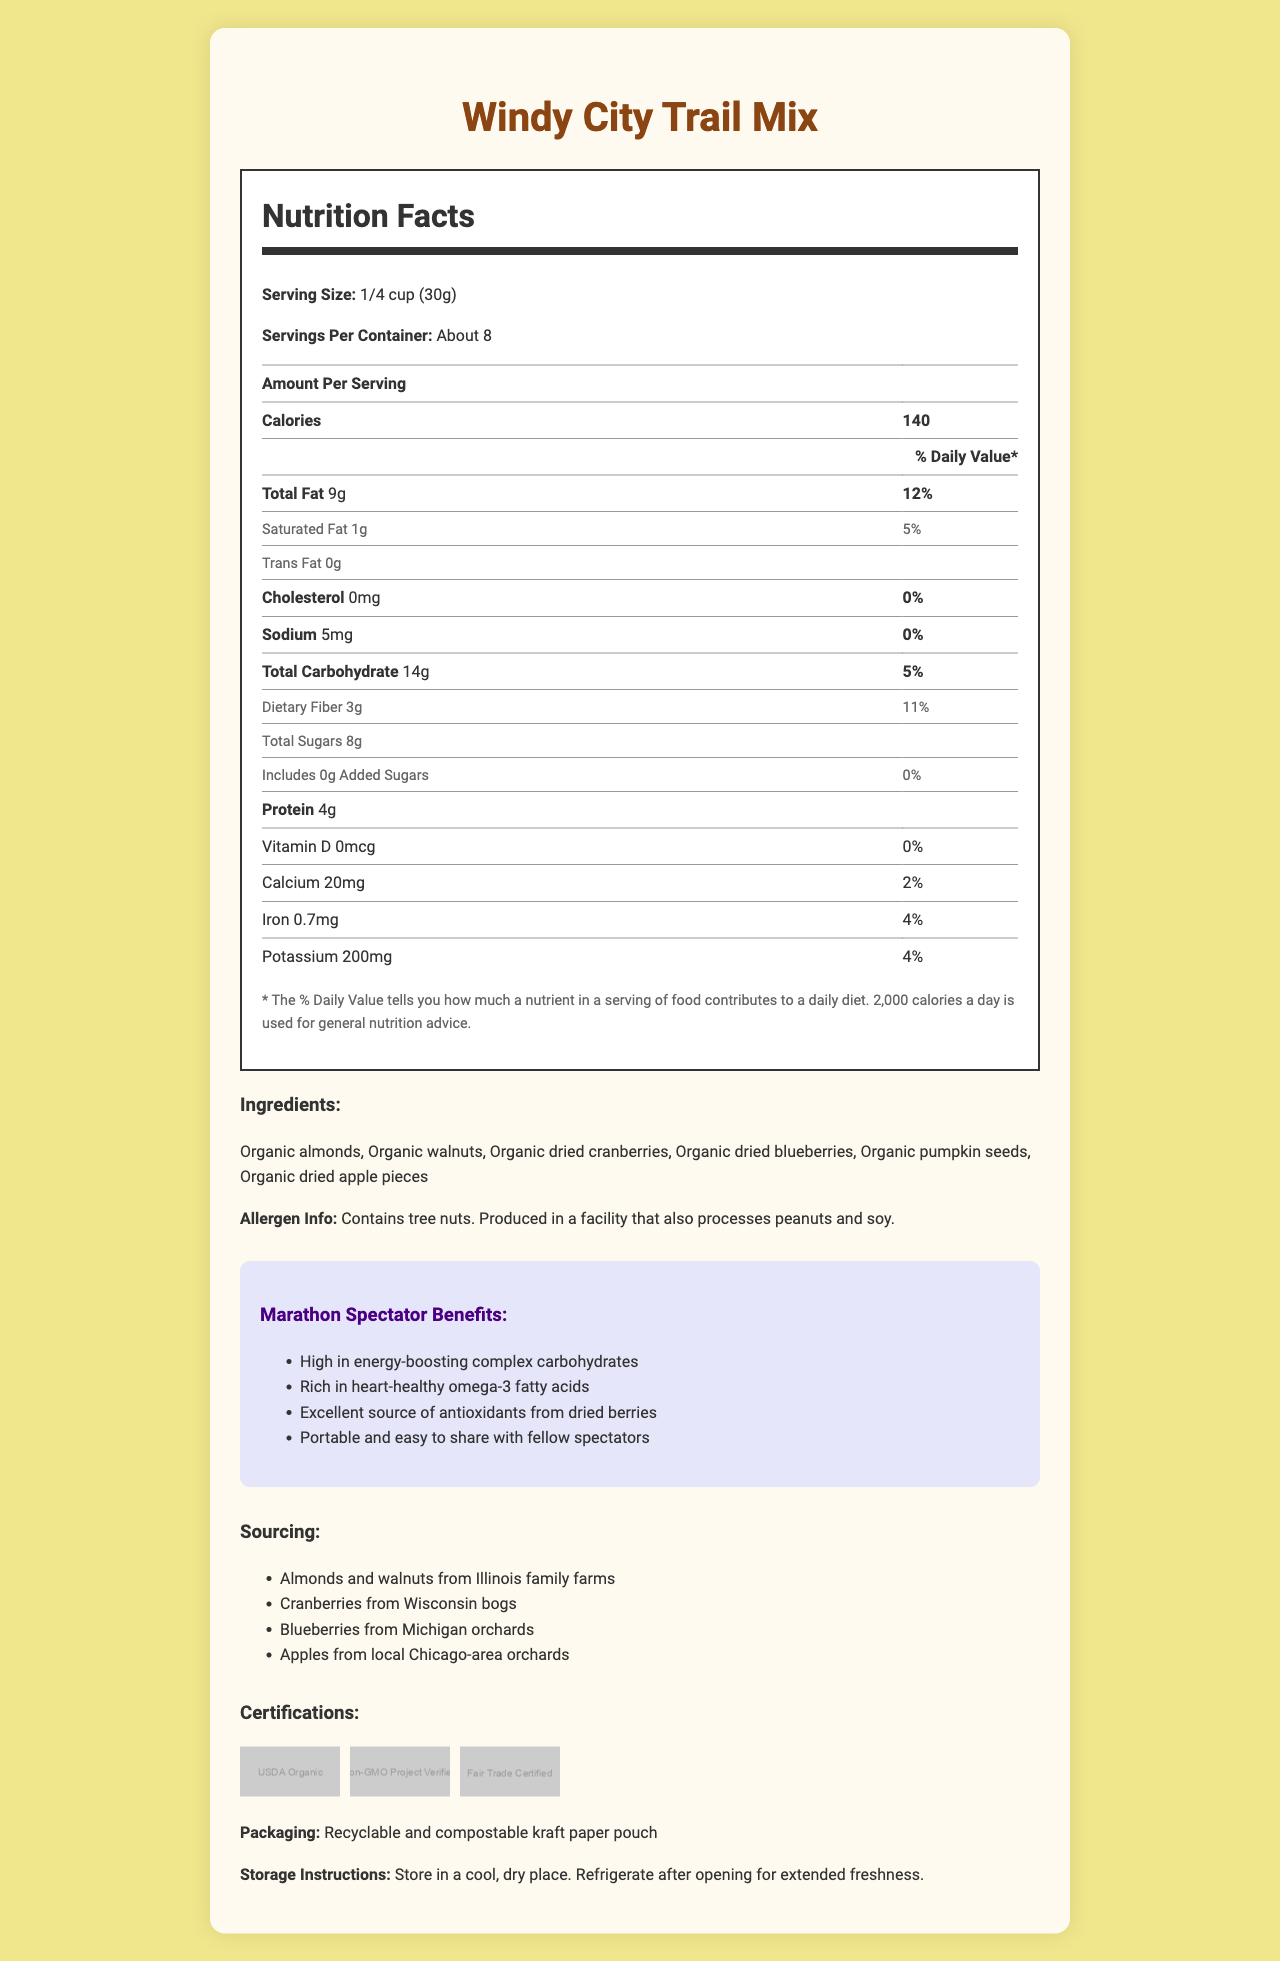How many calories are in one serving of Windy City Trail Mix? The calories per serving are listed as 140 in the nutrition facts section.
Answer: 140 What is the serving size of the Windy City Trail Mix? The serving size is specified as 1/4 cup (30g) in the nutrition facts section.
Answer: 1/4 cup (30g) How much protein is there in a serving of Windy City Trail Mix? The protein content is listed as 4g per serving in the nutrition facts section.
Answer: 4g What percentage of the daily value of dietary fiber is in one serving? The document states that the daily value percentage of dietary fiber per serving is 11%.
Answer: 11% What are the ingredients of Windy City Trail Mix? The list of ingredients is provided in the document.
Answer: Organic almonds, Organic walnuts, Organic dried cranberries, Organic dried blueberries, Organic pumpkin seeds, Organic dried apple pieces What is the total amount of fat in one serving? A. 5g B. 7g C. 9g D. 12g The total fat per serving is listed as 9g in the nutrition facts section.
Answer: C. 9g Which of the following certifications does Windy City Trail Mix have? I. USDA Organic II. Non-GMO Project Verified III. Gluten-Free A. I, II B. I, III C. II, III D. All of the above The document lists USDA Organic, Non-GMO Project Verified, and Fair Trade Certified but not Gluten-Free.
Answer: A. I, II Does the Windy City Trail Mix contain any added sugars? The document states that there are 0g of added sugars.
Answer: No Can you determine from the document where the pumpkin seeds were sourced? The document does not specify the sourcing of the pumpkin seeds.
Answer: No Describe the main idea of the document. The document covers various aspects of the Windy City Trail Mix including its nutritional content, ingredients, specific benefits for marathon spectators, sources of its components, different certifications it has achieved, and information about its packaging and storage.
Answer: The document provides detailed nutrition facts, ingredients, allergen information, marathon spectator benefits, sourcing, certifications, packaging, and storage instructions for Windy City Trail Mix, a popular snack among marathon spectators. How many servings per container are there? The servings per container are stated as "About 8" in the nutrition facts section.
Answer: About 8 What is the daily value percentage for calcium in one serving? The document lists the daily value percentage for calcium as 2%.
Answer: 2% Does Windy City Trail Mix contain cholesterol? The document states the cholesterol content as 0mg.
Answer: No What is the total carbohydrate content in a serving of Windy City Trail Mix? The total carbohydrate content is listed as 14g per serving in the nutrition facts section.
Answer: 14g Is the packaging for Windy City Trail Mix eco-friendly? The document mentions that the packaging is recyclable and compostable kraft paper pouch.
Answer: Yes What does the % Daily Value on the nutrition label indicate? The document explains that the % Daily Value is based on a 2,000-calorie diet and indicates the nutrient contribution of a serving.
Answer: The % Daily Value tells you how much a nutrient in a serving of food contributes to a daily diet based on a 2,000-calorie diet. 